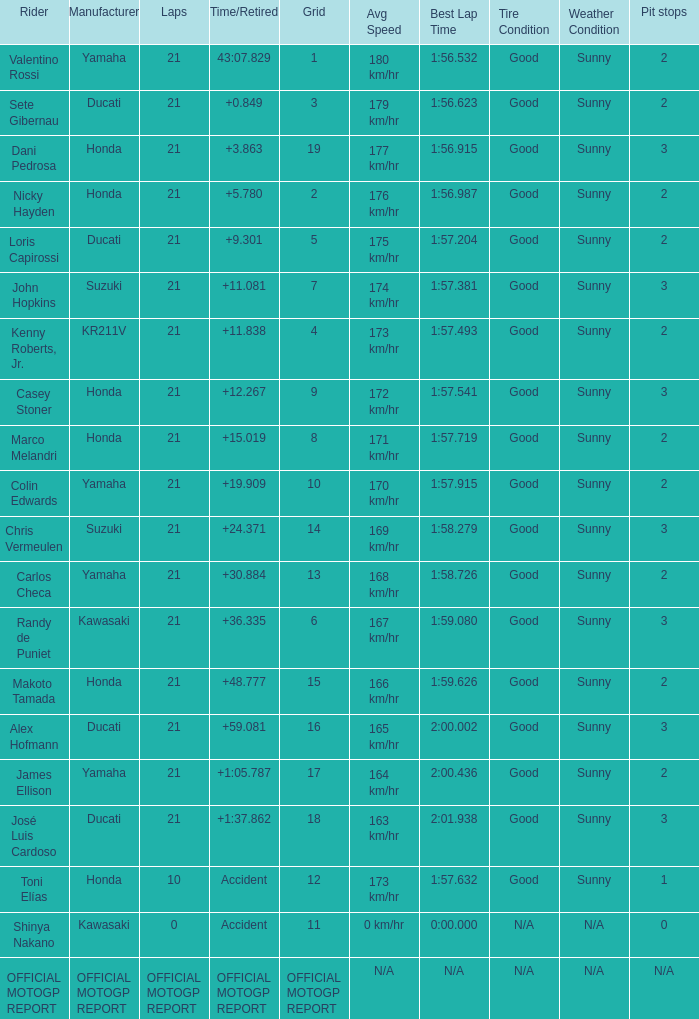WWhich rder had a vehicle manufactured by kr211v? Kenny Roberts, Jr. 